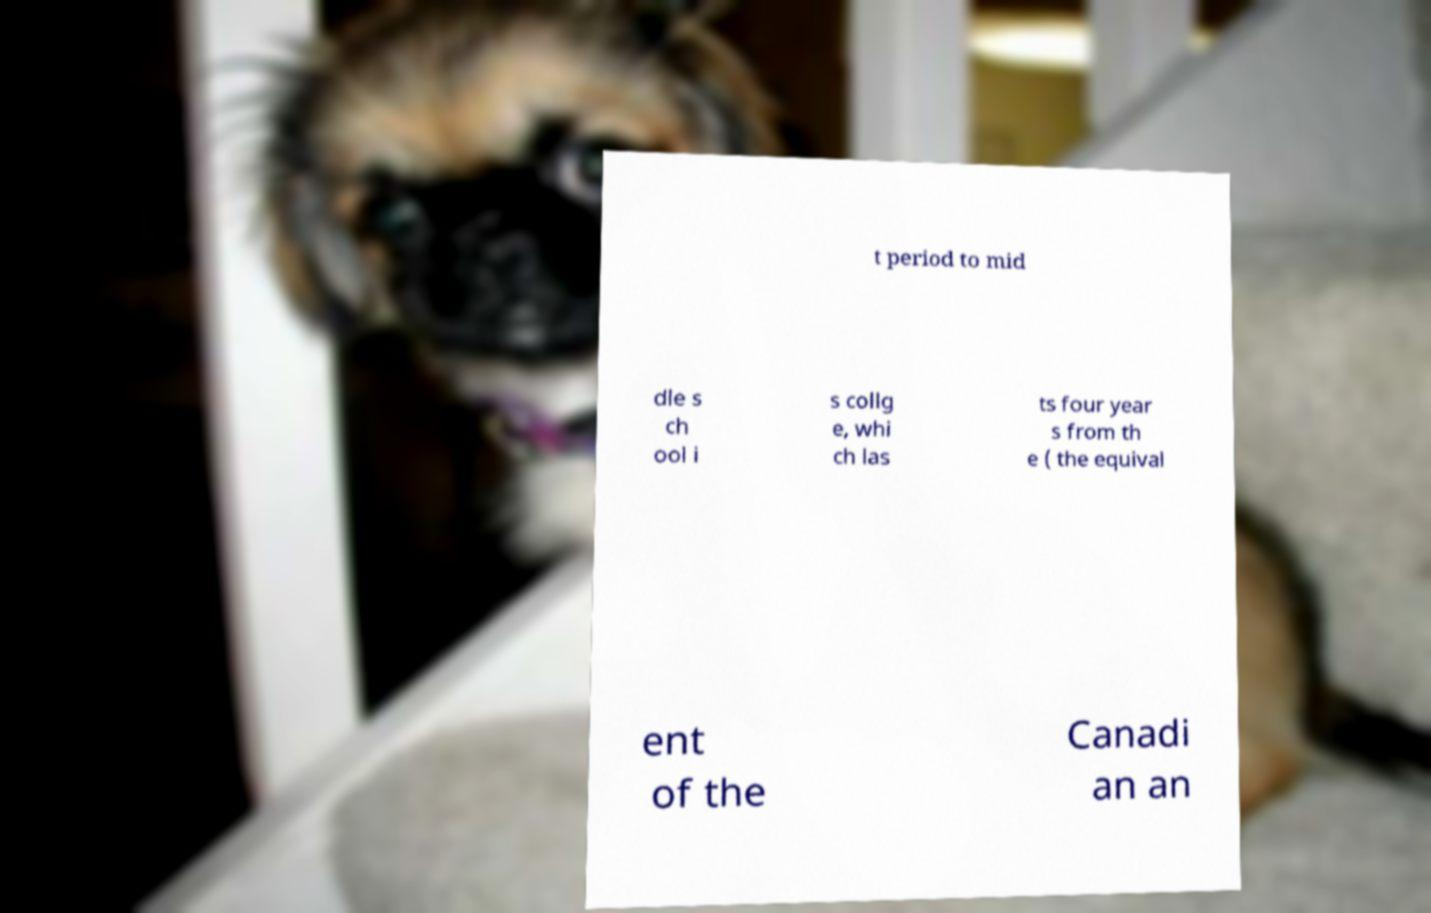For documentation purposes, I need the text within this image transcribed. Could you provide that? t period to mid dle s ch ool i s collg e, whi ch las ts four year s from th e ( the equival ent of the Canadi an an 